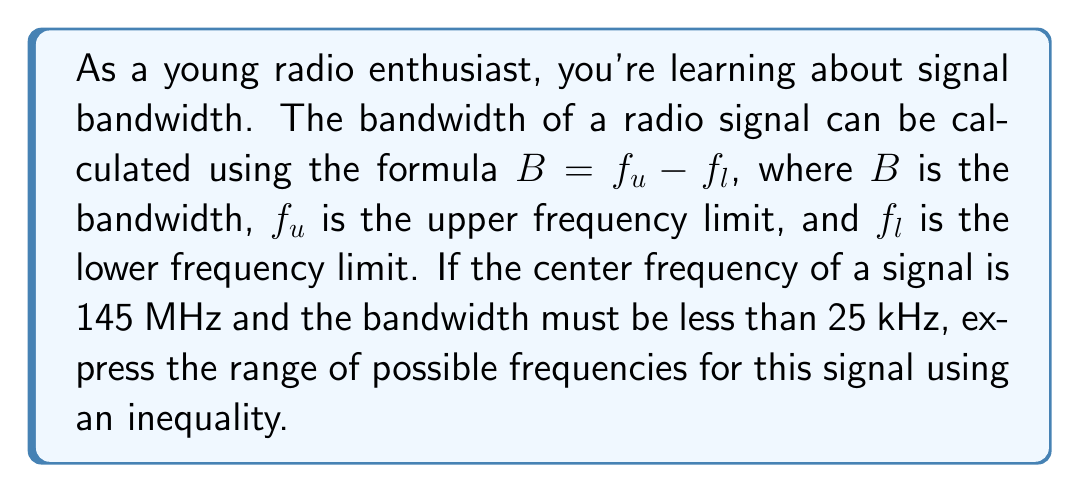Can you answer this question? Let's approach this step-by-step:

1) We know that bandwidth $B = f_u - f_l$, where $f_u$ is the upper frequency and $f_l$ is the lower frequency.

2) The center frequency $f_c$ is given as 145 MHz. We can express $f_u$ and $f_l$ in terms of $f_c$:
   
   $f_u = f_c + \frac{B}{2}$ and $f_l = f_c - \frac{B}{2}$

3) We're told that the bandwidth must be less than 25 kHz. In MHz, this is 0.025 MHz.
   So, $B < 0.025$ MHz

4) Now, let's express the range of frequencies:
   
   $f_c - \frac{B}{2} < f < f_c + \frac{B}{2}$

5) Substituting the values:
   
   $145 - \frac{0.025}{2} < f < 145 + \frac{0.025}{2}$

6) Simplifying:
   
   $144.9875 < f < 145.0125$

This inequality represents the range of possible frequencies for the signal.
Answer: $144.9875 < f < 145.0125$ (MHz) 